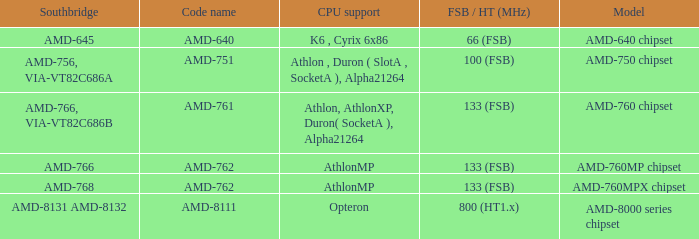What is the FSB / HT (MHz) when the Southbridge is amd-8131 amd-8132? 800 (HT1.x). 